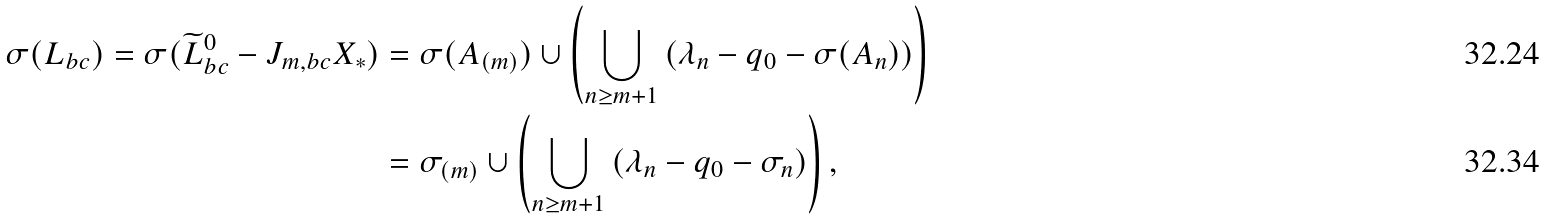<formula> <loc_0><loc_0><loc_500><loc_500>\sigma ( L _ { b c } ) = \sigma ( \widetilde { L } _ { b c } ^ { 0 } - J _ { m , b c } X _ { * } ) & = \sigma ( A _ { ( m ) } ) \cup \left ( \bigcup _ { n \geq m + 1 } \left ( \lambda _ { n } - q _ { 0 } - \sigma ( A _ { n } ) \right ) \right ) \\ & = \sigma _ { ( m ) } \cup \left ( \bigcup _ { n \geq m + 1 } \left ( \lambda _ { n } - q _ { 0 } - \sigma _ { n } \right ) \right ) ,</formula> 